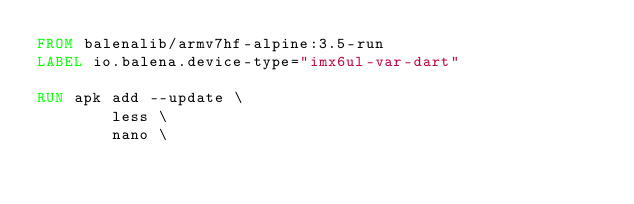<code> <loc_0><loc_0><loc_500><loc_500><_Dockerfile_>FROM balenalib/armv7hf-alpine:3.5-run
LABEL io.balena.device-type="imx6ul-var-dart"

RUN apk add --update \
		less \
		nano \</code> 